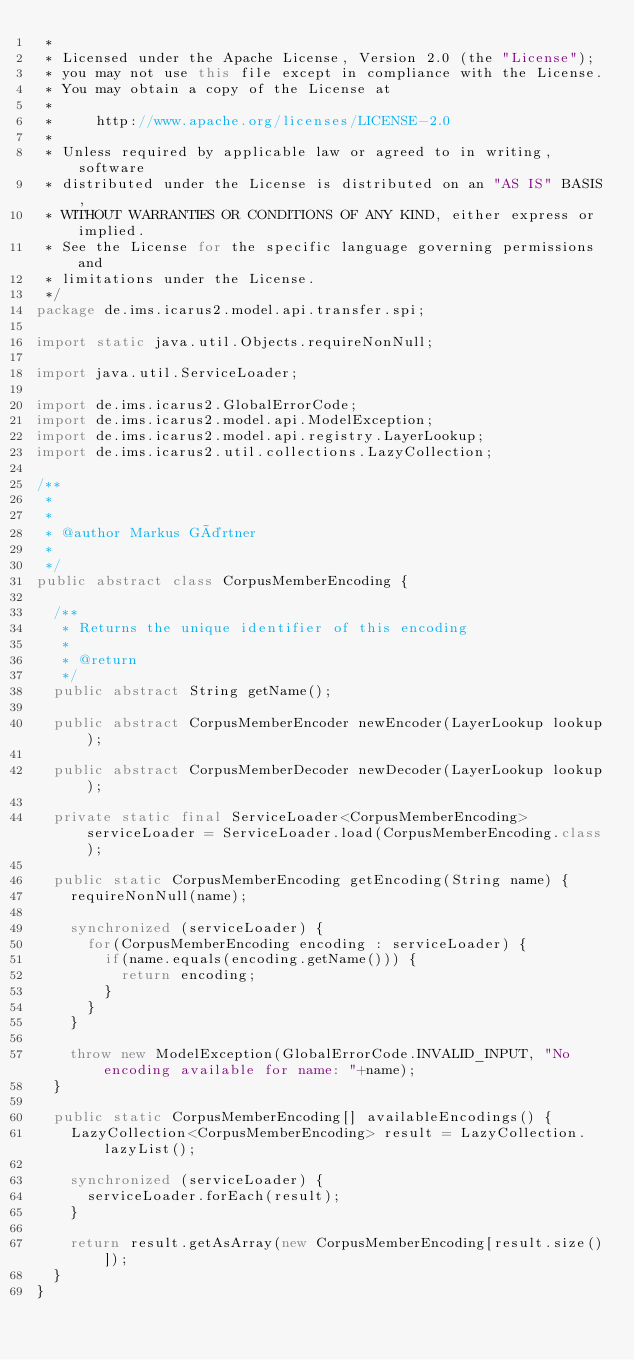Convert code to text. <code><loc_0><loc_0><loc_500><loc_500><_Java_> *
 * Licensed under the Apache License, Version 2.0 (the "License");
 * you may not use this file except in compliance with the License.
 * You may obtain a copy of the License at
 *
 *     http://www.apache.org/licenses/LICENSE-2.0
 *
 * Unless required by applicable law or agreed to in writing, software
 * distributed under the License is distributed on an "AS IS" BASIS,
 * WITHOUT WARRANTIES OR CONDITIONS OF ANY KIND, either express or implied.
 * See the License for the specific language governing permissions and
 * limitations under the License.
 */
package de.ims.icarus2.model.api.transfer.spi;

import static java.util.Objects.requireNonNull;

import java.util.ServiceLoader;

import de.ims.icarus2.GlobalErrorCode;
import de.ims.icarus2.model.api.ModelException;
import de.ims.icarus2.model.api.registry.LayerLookup;
import de.ims.icarus2.util.collections.LazyCollection;

/**
 *
 *
 * @author Markus Gärtner
 *
 */
public abstract class CorpusMemberEncoding {

	/**
	 * Returns the unique identifier of this encoding
	 *
	 * @return
	 */
	public abstract String getName();

	public abstract CorpusMemberEncoder newEncoder(LayerLookup lookup);

	public abstract CorpusMemberDecoder newDecoder(LayerLookup lookup);

	private static final ServiceLoader<CorpusMemberEncoding> serviceLoader = ServiceLoader.load(CorpusMemberEncoding.class);

	public static CorpusMemberEncoding getEncoding(String name) {
		requireNonNull(name);

		synchronized (serviceLoader) {
			for(CorpusMemberEncoding encoding : serviceLoader) {
				if(name.equals(encoding.getName())) {
					return encoding;
				}
			}
		}

		throw new ModelException(GlobalErrorCode.INVALID_INPUT, "No encoding available for name: "+name);
	}

	public static CorpusMemberEncoding[] availableEncodings() {
		LazyCollection<CorpusMemberEncoding> result = LazyCollection.lazyList();

		synchronized (serviceLoader) {
			serviceLoader.forEach(result);
		}

		return result.getAsArray(new CorpusMemberEncoding[result.size()]);
	}
}
</code> 